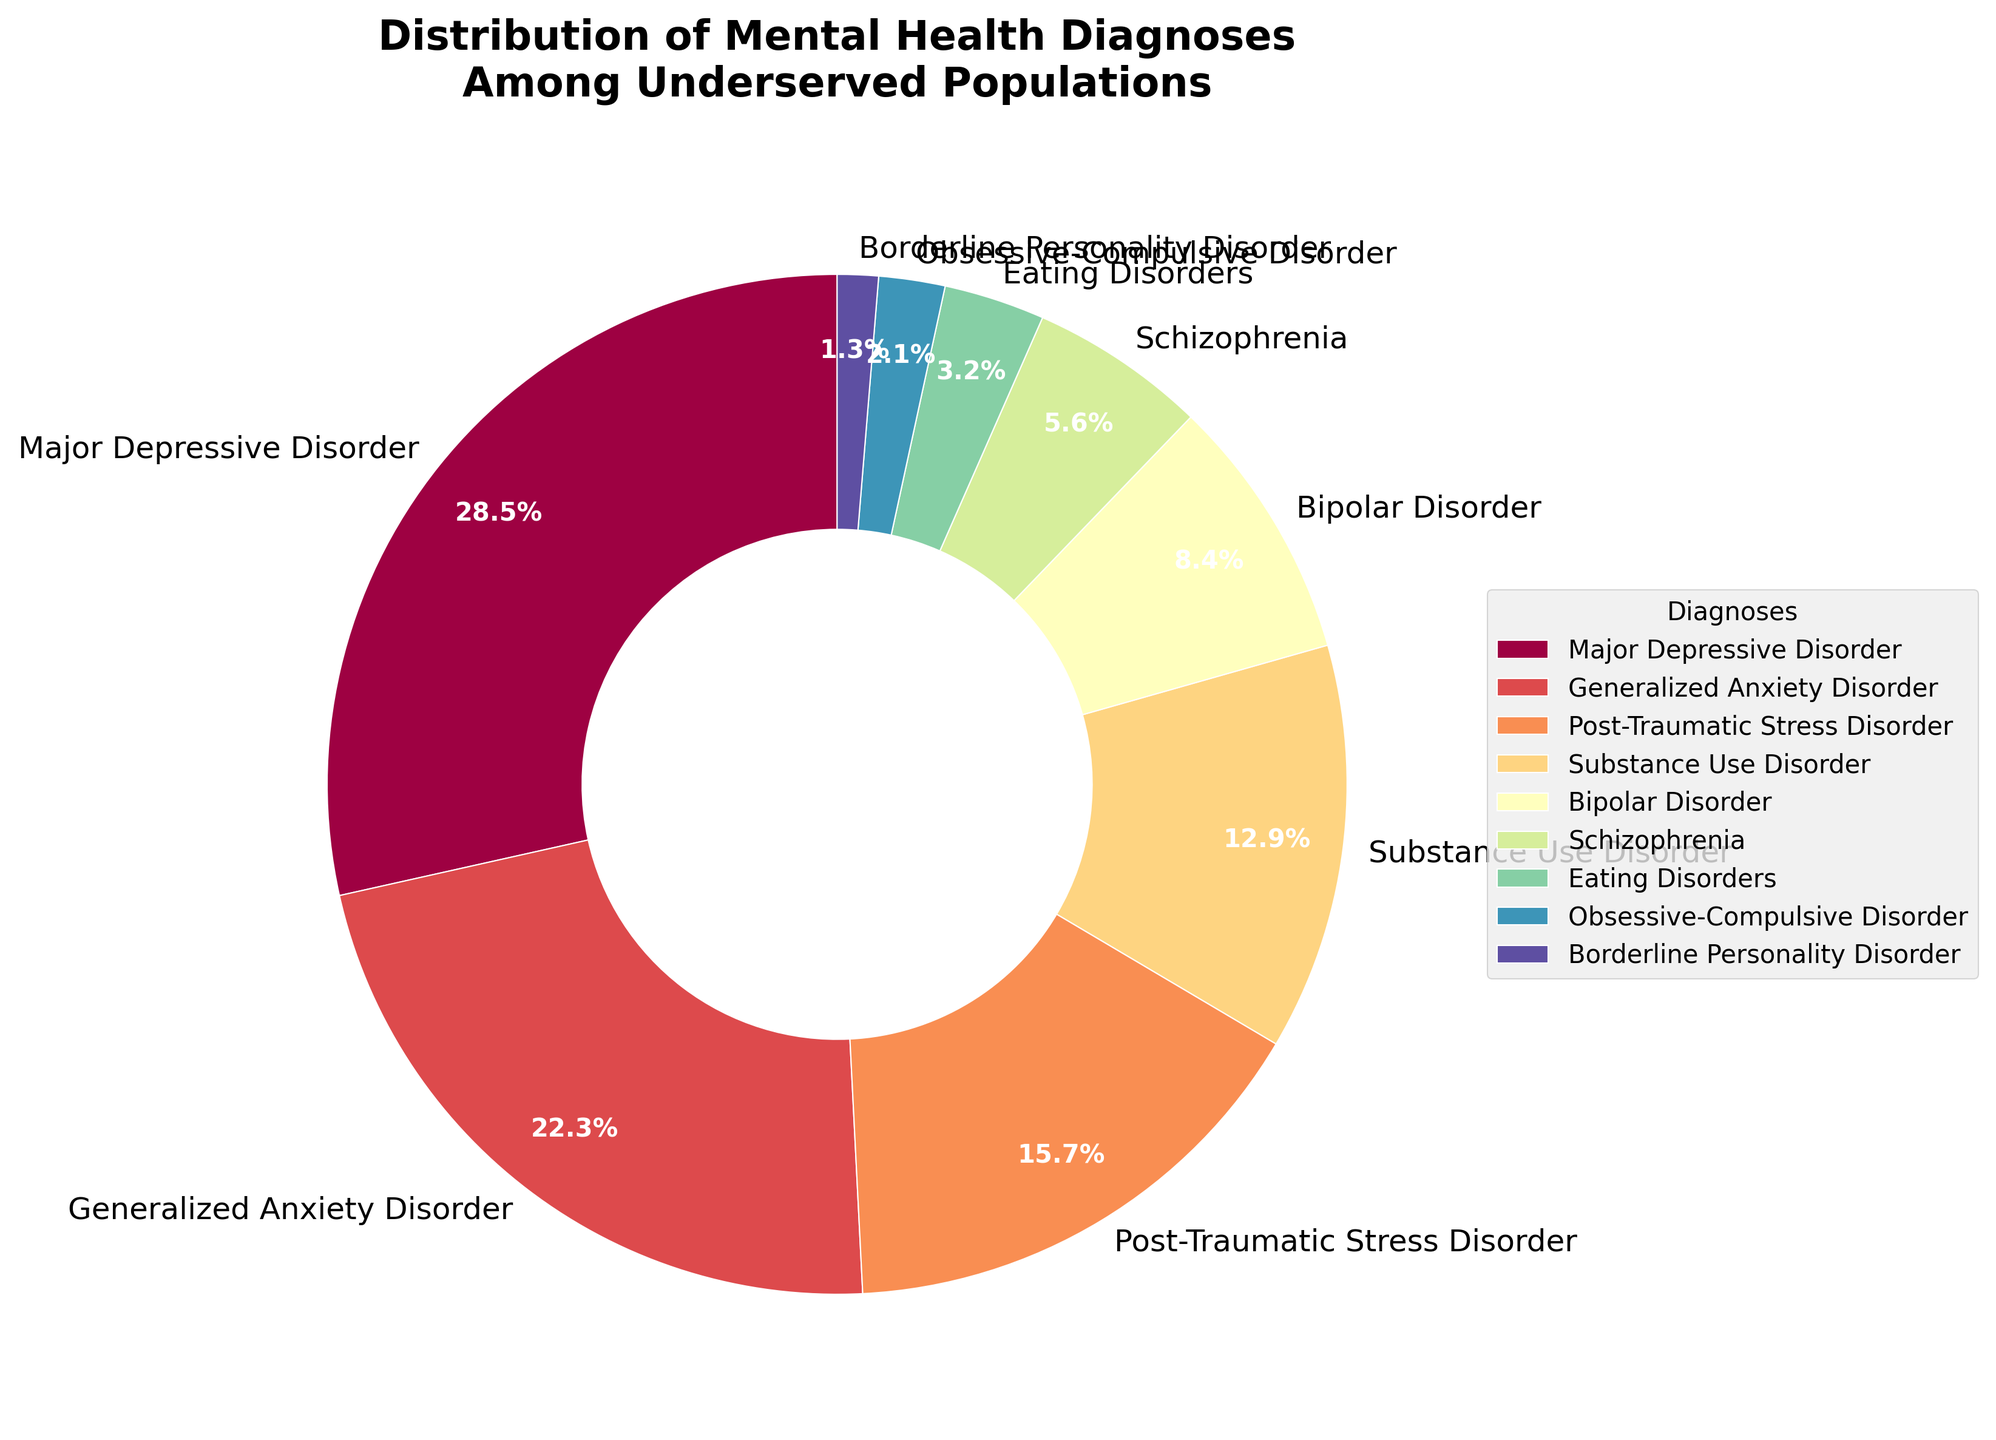Which mental health diagnosis has the highest percentage among the underserved populations? To determine the diagnosis with the highest percentage, look at the slices of the pie chart and identify the largest slice. This corresponds to the label "Major Depressive Disorder" with 28.5%.
Answer: Major Depressive Disorder What is the combined percentage of Generalized Anxiety Disorder and Bipolar Disorder? Add the percentages for Generalized Anxiety Disorder (22.3%) and Bipolar Disorder (8.4%). The combined percentage is 22.3 + 8.4 = 30.7%.
Answer: 30.7% Which diagnosis has a lower percentage, Schizophrenia or Eating Disorders? Compare the slices labeled "Schizophrenia" and "Eating Disorders". Schizophrenia has 5.6% and Eating Disorders has 3.2%. Therefore, Eating Disorders has the lower percentage.
Answer: Eating Disorders What is the total percentage of mental health diagnoses represented by the three least common disorders? Identify the three smallest slices, which are Borderline Personality Disorder (1.3%), Obsessive-Compulsive Disorder (2.1%), and Eating Disorders (3.2%). Add these percentages: 1.3 + 2.1 + 3.2 = 6.6%. This is the total percentage for the three least common disorders.
Answer: 6.6% Are there any disorders that represent more than 25% of the total? Review the percentages of each disorder. Major Depressive Disorder is the only slice that exceeds 25%, specifically at 28.5%.
Answer: Yes, Major Depressive Disorder Which disorders combined make up approximately half of the total distribution? Review the slices one by one until the total reaches approximately 50%. Major Depressive Disorder (28.5%) and Generalized Anxiety Disorder (22.3%) together account for 28.5 + 22.3 = 50.8% of the distribution.
Answer: Major Depressive Disorder and Generalized Anxiety Disorder 